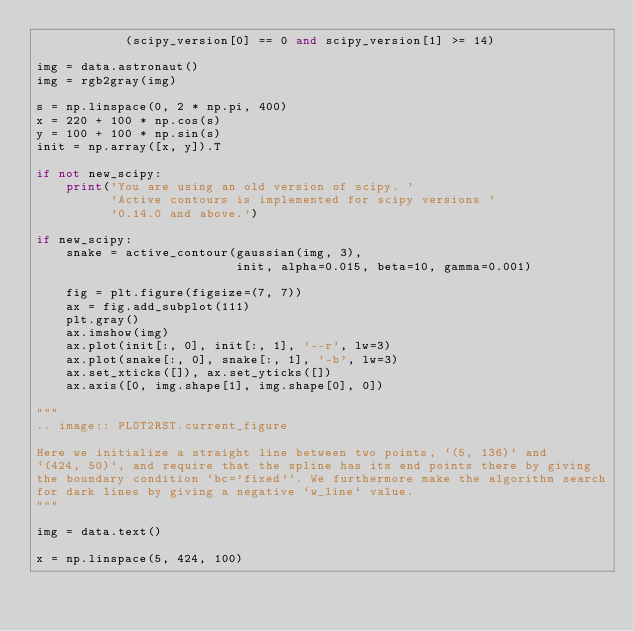<code> <loc_0><loc_0><loc_500><loc_500><_Python_>            (scipy_version[0] == 0 and scipy_version[1] >= 14)

img = data.astronaut()
img = rgb2gray(img)

s = np.linspace(0, 2 * np.pi, 400)
x = 220 + 100 * np.cos(s)
y = 100 + 100 * np.sin(s)
init = np.array([x, y]).T

if not new_scipy:
    print('You are using an old version of scipy. '
          'Active contours is implemented for scipy versions '
          '0.14.0 and above.')

if new_scipy:
    snake = active_contour(gaussian(img, 3),
                           init, alpha=0.015, beta=10, gamma=0.001)

    fig = plt.figure(figsize=(7, 7))
    ax = fig.add_subplot(111)
    plt.gray()
    ax.imshow(img)
    ax.plot(init[:, 0], init[:, 1], '--r', lw=3)
    ax.plot(snake[:, 0], snake[:, 1], '-b', lw=3)
    ax.set_xticks([]), ax.set_yticks([])
    ax.axis([0, img.shape[1], img.shape[0], 0])

"""
.. image:: PLOT2RST.current_figure

Here we initialize a straight line between two points, `(5, 136)` and
`(424, 50)`, and require that the spline has its end points there by giving
the boundary condition `bc='fixed'`. We furthermore make the algorithm search
for dark lines by giving a negative `w_line` value.
"""

img = data.text()

x = np.linspace(5, 424, 100)</code> 